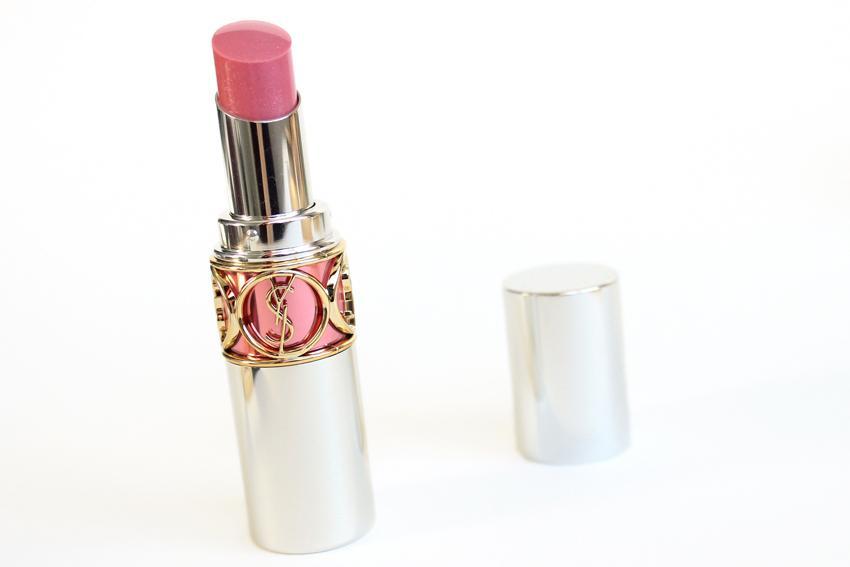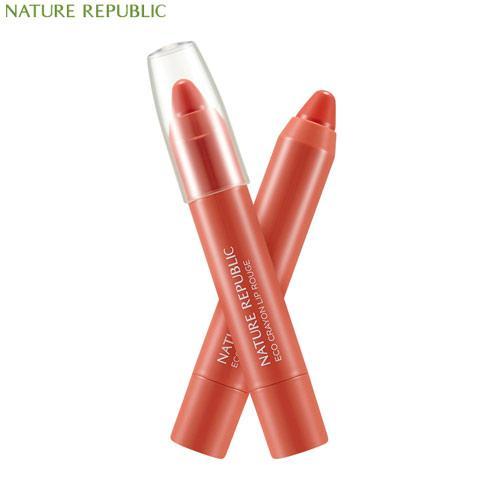The first image is the image on the left, the second image is the image on the right. For the images displayed, is the sentence "In one of the photos, there are two sticks of lipstick crossing each other." factually correct? Answer yes or no. Yes. The first image is the image on the left, the second image is the image on the right. Considering the images on both sides, is "There are 2 lipstick pencils crossed neatly like an X and one has the cap off." valid? Answer yes or no. Yes. 